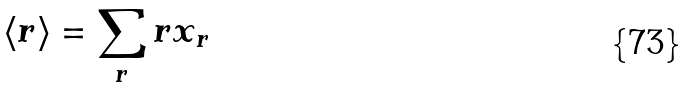Convert formula to latex. <formula><loc_0><loc_0><loc_500><loc_500>\left \langle r \right \rangle = \sum _ { r } r x _ { r }</formula> 